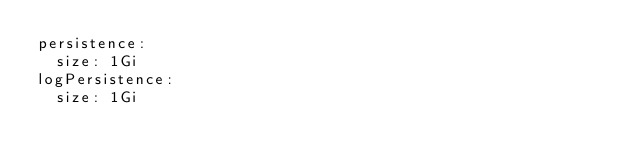Convert code to text. <code><loc_0><loc_0><loc_500><loc_500><_YAML_>persistence:
  size: 1Gi
logPersistence:
  size: 1Gi
</code> 